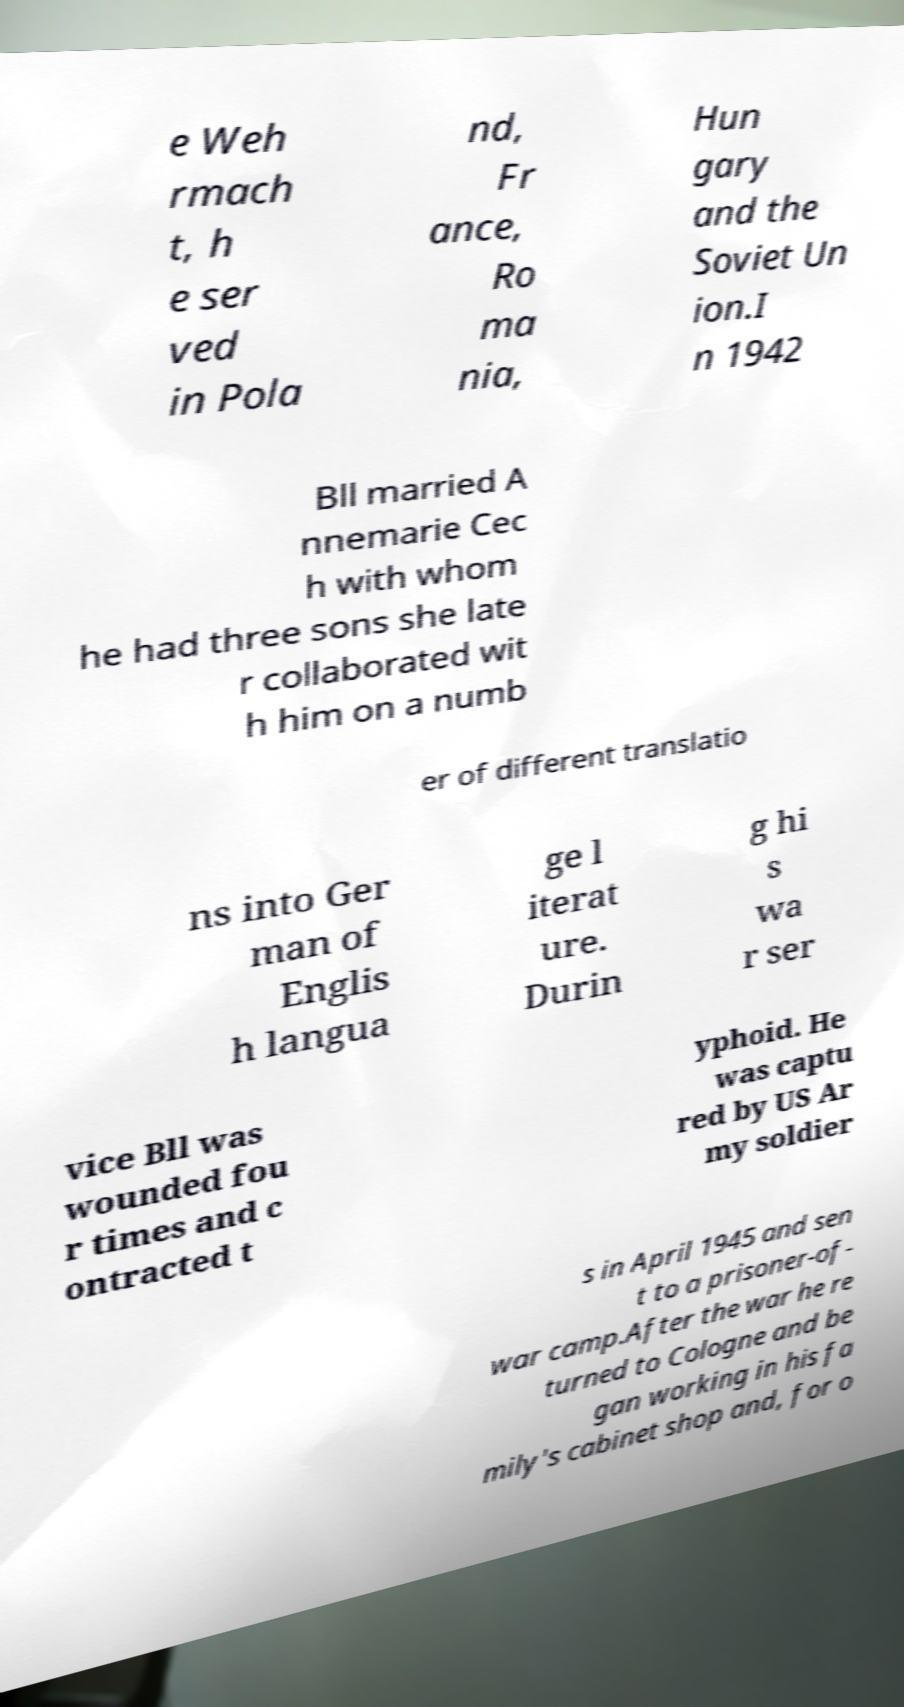Can you accurately transcribe the text from the provided image for me? e Weh rmach t, h e ser ved in Pola nd, Fr ance, Ro ma nia, Hun gary and the Soviet Un ion.I n 1942 Bll married A nnemarie Cec h with whom he had three sons she late r collaborated wit h him on a numb er of different translatio ns into Ger man of Englis h langua ge l iterat ure. Durin g hi s wa r ser vice Bll was wounded fou r times and c ontracted t yphoid. He was captu red by US Ar my soldier s in April 1945 and sen t to a prisoner-of- war camp.After the war he re turned to Cologne and be gan working in his fa mily's cabinet shop and, for o 